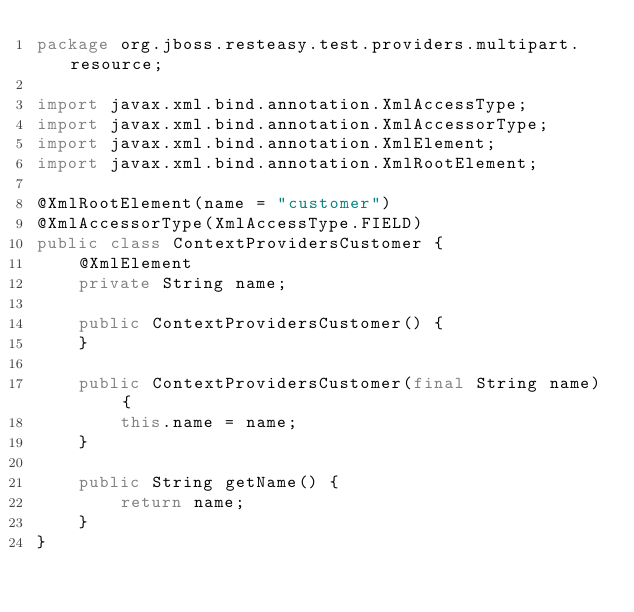<code> <loc_0><loc_0><loc_500><loc_500><_Java_>package org.jboss.resteasy.test.providers.multipart.resource;

import javax.xml.bind.annotation.XmlAccessType;
import javax.xml.bind.annotation.XmlAccessorType;
import javax.xml.bind.annotation.XmlElement;
import javax.xml.bind.annotation.XmlRootElement;

@XmlRootElement(name = "customer")
@XmlAccessorType(XmlAccessType.FIELD)
public class ContextProvidersCustomer {
    @XmlElement
    private String name;

    public ContextProvidersCustomer() {
    }

    public ContextProvidersCustomer(final String name) {
        this.name = name;
    }

    public String getName() {
        return name;
    }
}
</code> 